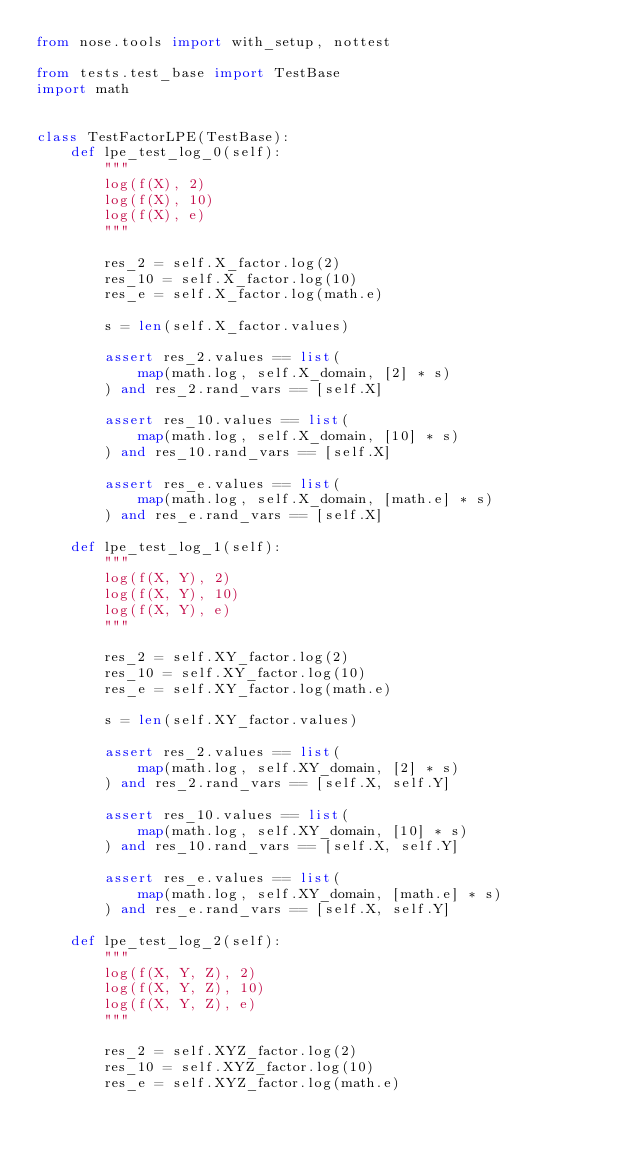<code> <loc_0><loc_0><loc_500><loc_500><_Python_>from nose.tools import with_setup, nottest

from tests.test_base import TestBase
import math


class TestFactorLPE(TestBase):
    def lpe_test_log_0(self):
        """
        log(f(X), 2)
        log(f(X), 10)
        log(f(X), e)
        """

        res_2 = self.X_factor.log(2)
        res_10 = self.X_factor.log(10)
        res_e = self.X_factor.log(math.e)

        s = len(self.X_factor.values)

        assert res_2.values == list(
            map(math.log, self.X_domain, [2] * s)
        ) and res_2.rand_vars == [self.X]

        assert res_10.values == list(
            map(math.log, self.X_domain, [10] * s)
        ) and res_10.rand_vars == [self.X]

        assert res_e.values == list(
            map(math.log, self.X_domain, [math.e] * s)
        ) and res_e.rand_vars == [self.X]

    def lpe_test_log_1(self):
        """
        log(f(X, Y), 2)
        log(f(X, Y), 10)
        log(f(X, Y), e)
        """

        res_2 = self.XY_factor.log(2)
        res_10 = self.XY_factor.log(10)
        res_e = self.XY_factor.log(math.e)

        s = len(self.XY_factor.values)

        assert res_2.values == list(
            map(math.log, self.XY_domain, [2] * s)
        ) and res_2.rand_vars == [self.X, self.Y]

        assert res_10.values == list(
            map(math.log, self.XY_domain, [10] * s)
        ) and res_10.rand_vars == [self.X, self.Y]

        assert res_e.values == list(
            map(math.log, self.XY_domain, [math.e] * s)
        ) and res_e.rand_vars == [self.X, self.Y]

    def lpe_test_log_2(self):
        """
        log(f(X, Y, Z), 2)
        log(f(X, Y, Z), 10)
        log(f(X, Y, Z), e)
        """

        res_2 = self.XYZ_factor.log(2)
        res_10 = self.XYZ_factor.log(10)
        res_e = self.XYZ_factor.log(math.e)
</code> 